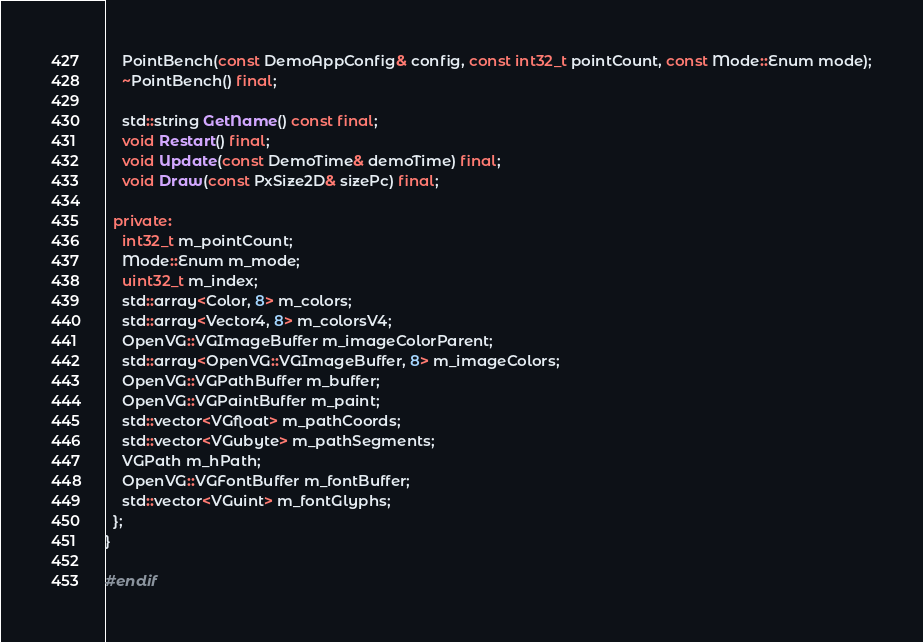Convert code to text. <code><loc_0><loc_0><loc_500><loc_500><_C++_>
    PointBench(const DemoAppConfig& config, const int32_t pointCount, const Mode::Enum mode);
    ~PointBench() final;

    std::string GetName() const final;
    void Restart() final;
    void Update(const DemoTime& demoTime) final;
    void Draw(const PxSize2D& sizePc) final;

  private:
    int32_t m_pointCount;
    Mode::Enum m_mode;
    uint32_t m_index;
    std::array<Color, 8> m_colors;
    std::array<Vector4, 8> m_colorsV4;
    OpenVG::VGImageBuffer m_imageColorParent;
    std::array<OpenVG::VGImageBuffer, 8> m_imageColors;
    OpenVG::VGPathBuffer m_buffer;
    OpenVG::VGPaintBuffer m_paint;
    std::vector<VGfloat> m_pathCoords;
    std::vector<VGubyte> m_pathSegments;
    VGPath m_hPath;
    OpenVG::VGFontBuffer m_fontBuffer;
    std::vector<VGuint> m_fontGlyphs;
  };
}

#endif
</code> 